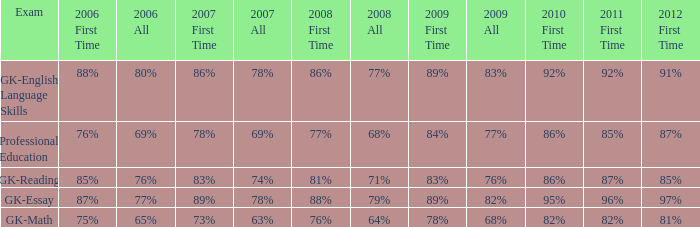What is the percentage for all in 2008 when all in 2007 was 69%? 68%. 